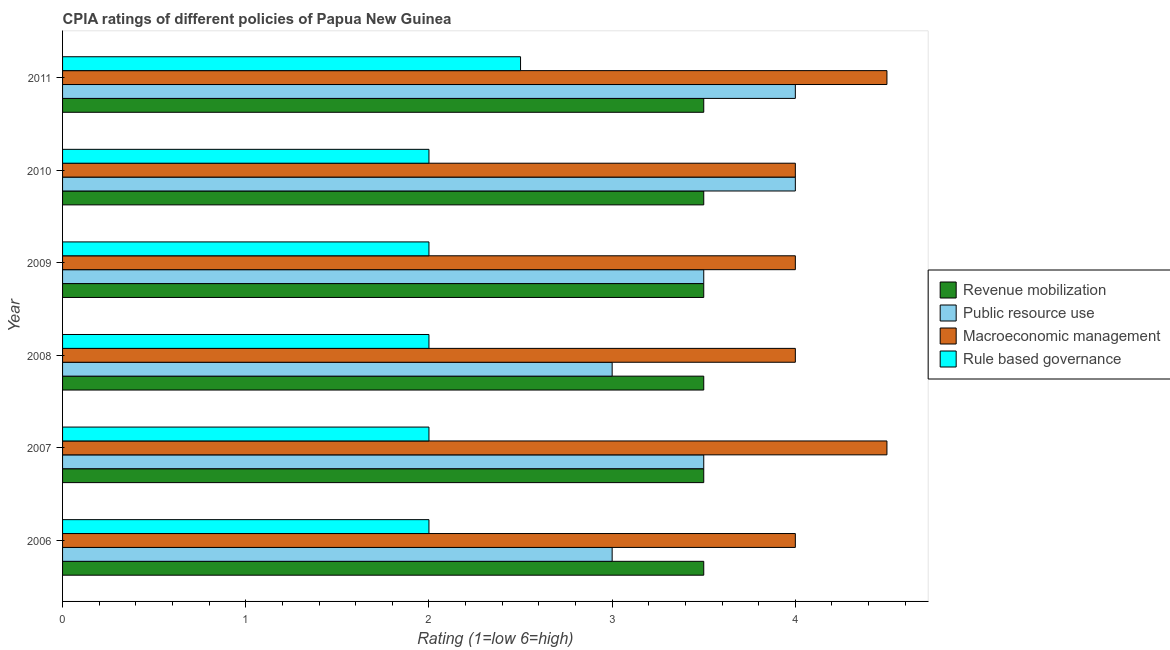How many groups of bars are there?
Provide a succinct answer. 6. Are the number of bars on each tick of the Y-axis equal?
Ensure brevity in your answer.  Yes. What is the label of the 1st group of bars from the top?
Your response must be concise. 2011. In how many cases, is the number of bars for a given year not equal to the number of legend labels?
Your answer should be very brief. 0. Across all years, what is the maximum cpia rating of public resource use?
Your response must be concise. 4. Across all years, what is the minimum cpia rating of macroeconomic management?
Ensure brevity in your answer.  4. What is the total cpia rating of revenue mobilization in the graph?
Provide a short and direct response. 21. What is the difference between the cpia rating of rule based governance in 2006 and that in 2009?
Provide a short and direct response. 0. What is the average cpia rating of macroeconomic management per year?
Your answer should be compact. 4.17. In how many years, is the cpia rating of public resource use greater than 2.8 ?
Your answer should be compact. 6. What is the ratio of the cpia rating of rule based governance in 2006 to that in 2007?
Your answer should be very brief. 1. What is the difference between the highest and the second highest cpia rating of revenue mobilization?
Provide a succinct answer. 0. What is the difference between the highest and the lowest cpia rating of macroeconomic management?
Ensure brevity in your answer.  0.5. In how many years, is the cpia rating of public resource use greater than the average cpia rating of public resource use taken over all years?
Make the answer very short. 2. Is the sum of the cpia rating of rule based governance in 2006 and 2009 greater than the maximum cpia rating of macroeconomic management across all years?
Your answer should be very brief. No. Is it the case that in every year, the sum of the cpia rating of public resource use and cpia rating of rule based governance is greater than the sum of cpia rating of macroeconomic management and cpia rating of revenue mobilization?
Offer a very short reply. No. What does the 4th bar from the top in 2006 represents?
Give a very brief answer. Revenue mobilization. What does the 1st bar from the bottom in 2007 represents?
Ensure brevity in your answer.  Revenue mobilization. Is it the case that in every year, the sum of the cpia rating of revenue mobilization and cpia rating of public resource use is greater than the cpia rating of macroeconomic management?
Offer a terse response. Yes. Does the graph contain any zero values?
Offer a very short reply. No. Does the graph contain grids?
Offer a very short reply. No. How many legend labels are there?
Your answer should be very brief. 4. What is the title of the graph?
Your response must be concise. CPIA ratings of different policies of Papua New Guinea. Does "Taxes on income" appear as one of the legend labels in the graph?
Ensure brevity in your answer.  No. What is the label or title of the Y-axis?
Provide a short and direct response. Year. What is the Rating (1=low 6=high) of Revenue mobilization in 2006?
Provide a short and direct response. 3.5. What is the Rating (1=low 6=high) in Macroeconomic management in 2006?
Give a very brief answer. 4. What is the Rating (1=low 6=high) in Rule based governance in 2006?
Your response must be concise. 2. What is the Rating (1=low 6=high) of Public resource use in 2007?
Ensure brevity in your answer.  3.5. What is the Rating (1=low 6=high) in Macroeconomic management in 2007?
Provide a succinct answer. 4.5. What is the Rating (1=low 6=high) of Revenue mobilization in 2008?
Your answer should be very brief. 3.5. What is the Rating (1=low 6=high) of Macroeconomic management in 2008?
Provide a short and direct response. 4. What is the Rating (1=low 6=high) in Public resource use in 2009?
Ensure brevity in your answer.  3.5. What is the Rating (1=low 6=high) of Macroeconomic management in 2009?
Provide a short and direct response. 4. What is the Rating (1=low 6=high) of Rule based governance in 2009?
Provide a short and direct response. 2. What is the Rating (1=low 6=high) of Revenue mobilization in 2010?
Offer a terse response. 3.5. What is the Rating (1=low 6=high) in Public resource use in 2010?
Your response must be concise. 4. What is the Rating (1=low 6=high) of Macroeconomic management in 2010?
Offer a very short reply. 4. What is the Rating (1=low 6=high) in Public resource use in 2011?
Provide a short and direct response. 4. What is the Rating (1=low 6=high) in Macroeconomic management in 2011?
Offer a very short reply. 4.5. What is the Rating (1=low 6=high) of Rule based governance in 2011?
Make the answer very short. 2.5. Across all years, what is the maximum Rating (1=low 6=high) in Revenue mobilization?
Provide a short and direct response. 3.5. Across all years, what is the maximum Rating (1=low 6=high) of Public resource use?
Provide a short and direct response. 4. Across all years, what is the minimum Rating (1=low 6=high) in Revenue mobilization?
Keep it short and to the point. 3.5. What is the total Rating (1=low 6=high) of Public resource use in the graph?
Ensure brevity in your answer.  21. What is the difference between the Rating (1=low 6=high) in Revenue mobilization in 2006 and that in 2007?
Your answer should be compact. 0. What is the difference between the Rating (1=low 6=high) in Revenue mobilization in 2006 and that in 2008?
Give a very brief answer. 0. What is the difference between the Rating (1=low 6=high) of Public resource use in 2006 and that in 2008?
Your answer should be very brief. 0. What is the difference between the Rating (1=low 6=high) in Rule based governance in 2006 and that in 2008?
Offer a very short reply. 0. What is the difference between the Rating (1=low 6=high) in Revenue mobilization in 2006 and that in 2009?
Make the answer very short. 0. What is the difference between the Rating (1=low 6=high) in Revenue mobilization in 2006 and that in 2010?
Provide a short and direct response. 0. What is the difference between the Rating (1=low 6=high) of Macroeconomic management in 2006 and that in 2010?
Ensure brevity in your answer.  0. What is the difference between the Rating (1=low 6=high) of Rule based governance in 2006 and that in 2010?
Provide a short and direct response. 0. What is the difference between the Rating (1=low 6=high) in Public resource use in 2006 and that in 2011?
Offer a very short reply. -1. What is the difference between the Rating (1=low 6=high) in Public resource use in 2007 and that in 2008?
Provide a succinct answer. 0.5. What is the difference between the Rating (1=low 6=high) in Rule based governance in 2007 and that in 2008?
Your answer should be very brief. 0. What is the difference between the Rating (1=low 6=high) in Public resource use in 2007 and that in 2009?
Offer a very short reply. 0. What is the difference between the Rating (1=low 6=high) of Rule based governance in 2007 and that in 2009?
Ensure brevity in your answer.  0. What is the difference between the Rating (1=low 6=high) of Revenue mobilization in 2007 and that in 2010?
Provide a succinct answer. 0. What is the difference between the Rating (1=low 6=high) in Public resource use in 2007 and that in 2010?
Your answer should be very brief. -0.5. What is the difference between the Rating (1=low 6=high) in Macroeconomic management in 2007 and that in 2010?
Offer a very short reply. 0.5. What is the difference between the Rating (1=low 6=high) of Revenue mobilization in 2007 and that in 2011?
Make the answer very short. 0. What is the difference between the Rating (1=low 6=high) of Revenue mobilization in 2008 and that in 2009?
Give a very brief answer. 0. What is the difference between the Rating (1=low 6=high) in Macroeconomic management in 2008 and that in 2009?
Give a very brief answer. 0. What is the difference between the Rating (1=low 6=high) of Macroeconomic management in 2008 and that in 2010?
Ensure brevity in your answer.  0. What is the difference between the Rating (1=low 6=high) in Rule based governance in 2008 and that in 2010?
Provide a succinct answer. 0. What is the difference between the Rating (1=low 6=high) in Public resource use in 2008 and that in 2011?
Offer a very short reply. -1. What is the difference between the Rating (1=low 6=high) in Macroeconomic management in 2008 and that in 2011?
Your response must be concise. -0.5. What is the difference between the Rating (1=low 6=high) of Rule based governance in 2008 and that in 2011?
Your response must be concise. -0.5. What is the difference between the Rating (1=low 6=high) in Macroeconomic management in 2009 and that in 2010?
Your response must be concise. 0. What is the difference between the Rating (1=low 6=high) in Revenue mobilization in 2009 and that in 2011?
Your answer should be very brief. 0. What is the difference between the Rating (1=low 6=high) of Public resource use in 2009 and that in 2011?
Give a very brief answer. -0.5. What is the difference between the Rating (1=low 6=high) of Macroeconomic management in 2009 and that in 2011?
Your response must be concise. -0.5. What is the difference between the Rating (1=low 6=high) of Public resource use in 2010 and that in 2011?
Your answer should be very brief. 0. What is the difference between the Rating (1=low 6=high) in Revenue mobilization in 2006 and the Rating (1=low 6=high) in Public resource use in 2007?
Make the answer very short. 0. What is the difference between the Rating (1=low 6=high) in Revenue mobilization in 2006 and the Rating (1=low 6=high) in Macroeconomic management in 2007?
Make the answer very short. -1. What is the difference between the Rating (1=low 6=high) of Public resource use in 2006 and the Rating (1=low 6=high) of Macroeconomic management in 2007?
Offer a very short reply. -1.5. What is the difference between the Rating (1=low 6=high) in Revenue mobilization in 2006 and the Rating (1=low 6=high) in Public resource use in 2008?
Offer a very short reply. 0.5. What is the difference between the Rating (1=low 6=high) in Revenue mobilization in 2006 and the Rating (1=low 6=high) in Macroeconomic management in 2008?
Provide a succinct answer. -0.5. What is the difference between the Rating (1=low 6=high) in Revenue mobilization in 2006 and the Rating (1=low 6=high) in Rule based governance in 2008?
Your response must be concise. 1.5. What is the difference between the Rating (1=low 6=high) of Revenue mobilization in 2006 and the Rating (1=low 6=high) of Rule based governance in 2009?
Offer a very short reply. 1.5. What is the difference between the Rating (1=low 6=high) of Public resource use in 2006 and the Rating (1=low 6=high) of Rule based governance in 2009?
Ensure brevity in your answer.  1. What is the difference between the Rating (1=low 6=high) of Revenue mobilization in 2006 and the Rating (1=low 6=high) of Public resource use in 2010?
Provide a succinct answer. -0.5. What is the difference between the Rating (1=low 6=high) in Revenue mobilization in 2006 and the Rating (1=low 6=high) in Rule based governance in 2010?
Your answer should be very brief. 1.5. What is the difference between the Rating (1=low 6=high) in Revenue mobilization in 2006 and the Rating (1=low 6=high) in Public resource use in 2011?
Provide a succinct answer. -0.5. What is the difference between the Rating (1=low 6=high) in Revenue mobilization in 2006 and the Rating (1=low 6=high) in Macroeconomic management in 2011?
Provide a short and direct response. -1. What is the difference between the Rating (1=low 6=high) in Macroeconomic management in 2006 and the Rating (1=low 6=high) in Rule based governance in 2011?
Give a very brief answer. 1.5. What is the difference between the Rating (1=low 6=high) in Revenue mobilization in 2007 and the Rating (1=low 6=high) in Macroeconomic management in 2008?
Your response must be concise. -0.5. What is the difference between the Rating (1=low 6=high) in Revenue mobilization in 2007 and the Rating (1=low 6=high) in Rule based governance in 2008?
Provide a succinct answer. 1.5. What is the difference between the Rating (1=low 6=high) in Macroeconomic management in 2007 and the Rating (1=low 6=high) in Rule based governance in 2008?
Your answer should be very brief. 2.5. What is the difference between the Rating (1=low 6=high) in Revenue mobilization in 2007 and the Rating (1=low 6=high) in Macroeconomic management in 2009?
Your answer should be very brief. -0.5. What is the difference between the Rating (1=low 6=high) in Revenue mobilization in 2007 and the Rating (1=low 6=high) in Rule based governance in 2009?
Keep it short and to the point. 1.5. What is the difference between the Rating (1=low 6=high) in Public resource use in 2007 and the Rating (1=low 6=high) in Macroeconomic management in 2009?
Give a very brief answer. -0.5. What is the difference between the Rating (1=low 6=high) in Public resource use in 2007 and the Rating (1=low 6=high) in Rule based governance in 2009?
Your response must be concise. 1.5. What is the difference between the Rating (1=low 6=high) in Revenue mobilization in 2007 and the Rating (1=low 6=high) in Public resource use in 2010?
Provide a short and direct response. -0.5. What is the difference between the Rating (1=low 6=high) in Revenue mobilization in 2007 and the Rating (1=low 6=high) in Macroeconomic management in 2010?
Keep it short and to the point. -0.5. What is the difference between the Rating (1=low 6=high) in Macroeconomic management in 2007 and the Rating (1=low 6=high) in Rule based governance in 2010?
Make the answer very short. 2.5. What is the difference between the Rating (1=low 6=high) in Revenue mobilization in 2007 and the Rating (1=low 6=high) in Public resource use in 2011?
Provide a short and direct response. -0.5. What is the difference between the Rating (1=low 6=high) of Revenue mobilization in 2007 and the Rating (1=low 6=high) of Rule based governance in 2011?
Your answer should be very brief. 1. What is the difference between the Rating (1=low 6=high) of Public resource use in 2007 and the Rating (1=low 6=high) of Macroeconomic management in 2011?
Offer a terse response. -1. What is the difference between the Rating (1=low 6=high) of Public resource use in 2007 and the Rating (1=low 6=high) of Rule based governance in 2011?
Your answer should be very brief. 1. What is the difference between the Rating (1=low 6=high) in Macroeconomic management in 2007 and the Rating (1=low 6=high) in Rule based governance in 2011?
Your response must be concise. 2. What is the difference between the Rating (1=low 6=high) in Revenue mobilization in 2008 and the Rating (1=low 6=high) in Macroeconomic management in 2009?
Give a very brief answer. -0.5. What is the difference between the Rating (1=low 6=high) in Public resource use in 2008 and the Rating (1=low 6=high) in Rule based governance in 2009?
Your response must be concise. 1. What is the difference between the Rating (1=low 6=high) in Macroeconomic management in 2008 and the Rating (1=low 6=high) in Rule based governance in 2009?
Your answer should be compact. 2. What is the difference between the Rating (1=low 6=high) of Revenue mobilization in 2008 and the Rating (1=low 6=high) of Public resource use in 2010?
Give a very brief answer. -0.5. What is the difference between the Rating (1=low 6=high) in Revenue mobilization in 2008 and the Rating (1=low 6=high) in Macroeconomic management in 2010?
Offer a very short reply. -0.5. What is the difference between the Rating (1=low 6=high) of Revenue mobilization in 2008 and the Rating (1=low 6=high) of Rule based governance in 2010?
Offer a very short reply. 1.5. What is the difference between the Rating (1=low 6=high) of Public resource use in 2008 and the Rating (1=low 6=high) of Macroeconomic management in 2010?
Your answer should be very brief. -1. What is the difference between the Rating (1=low 6=high) of Revenue mobilization in 2008 and the Rating (1=low 6=high) of Public resource use in 2011?
Provide a succinct answer. -0.5. What is the difference between the Rating (1=low 6=high) in Revenue mobilization in 2008 and the Rating (1=low 6=high) in Rule based governance in 2011?
Your answer should be compact. 1. What is the difference between the Rating (1=low 6=high) in Public resource use in 2008 and the Rating (1=low 6=high) in Macroeconomic management in 2011?
Your answer should be very brief. -1.5. What is the difference between the Rating (1=low 6=high) of Public resource use in 2008 and the Rating (1=low 6=high) of Rule based governance in 2011?
Your answer should be very brief. 0.5. What is the difference between the Rating (1=low 6=high) in Macroeconomic management in 2008 and the Rating (1=low 6=high) in Rule based governance in 2011?
Your answer should be compact. 1.5. What is the difference between the Rating (1=low 6=high) in Revenue mobilization in 2009 and the Rating (1=low 6=high) in Rule based governance in 2010?
Keep it short and to the point. 1.5. What is the difference between the Rating (1=low 6=high) of Public resource use in 2009 and the Rating (1=low 6=high) of Rule based governance in 2010?
Offer a terse response. 1.5. What is the difference between the Rating (1=low 6=high) of Macroeconomic management in 2009 and the Rating (1=low 6=high) of Rule based governance in 2010?
Your response must be concise. 2. What is the difference between the Rating (1=low 6=high) in Revenue mobilization in 2009 and the Rating (1=low 6=high) in Public resource use in 2011?
Offer a terse response. -0.5. What is the difference between the Rating (1=low 6=high) of Public resource use in 2009 and the Rating (1=low 6=high) of Macroeconomic management in 2011?
Your answer should be compact. -1. What is the difference between the Rating (1=low 6=high) of Macroeconomic management in 2009 and the Rating (1=low 6=high) of Rule based governance in 2011?
Your response must be concise. 1.5. What is the difference between the Rating (1=low 6=high) in Revenue mobilization in 2010 and the Rating (1=low 6=high) in Rule based governance in 2011?
Your answer should be compact. 1. What is the difference between the Rating (1=low 6=high) in Public resource use in 2010 and the Rating (1=low 6=high) in Rule based governance in 2011?
Your answer should be very brief. 1.5. What is the average Rating (1=low 6=high) in Macroeconomic management per year?
Offer a terse response. 4.17. What is the average Rating (1=low 6=high) of Rule based governance per year?
Your response must be concise. 2.08. In the year 2006, what is the difference between the Rating (1=low 6=high) of Public resource use and Rating (1=low 6=high) of Macroeconomic management?
Ensure brevity in your answer.  -1. In the year 2006, what is the difference between the Rating (1=low 6=high) in Macroeconomic management and Rating (1=low 6=high) in Rule based governance?
Keep it short and to the point. 2. In the year 2007, what is the difference between the Rating (1=low 6=high) of Revenue mobilization and Rating (1=low 6=high) of Macroeconomic management?
Ensure brevity in your answer.  -1. In the year 2007, what is the difference between the Rating (1=low 6=high) in Public resource use and Rating (1=low 6=high) in Rule based governance?
Ensure brevity in your answer.  1.5. In the year 2008, what is the difference between the Rating (1=low 6=high) of Revenue mobilization and Rating (1=low 6=high) of Macroeconomic management?
Offer a terse response. -0.5. In the year 2008, what is the difference between the Rating (1=low 6=high) of Public resource use and Rating (1=low 6=high) of Macroeconomic management?
Make the answer very short. -1. In the year 2009, what is the difference between the Rating (1=low 6=high) in Macroeconomic management and Rating (1=low 6=high) in Rule based governance?
Your answer should be very brief. 2. In the year 2010, what is the difference between the Rating (1=low 6=high) of Revenue mobilization and Rating (1=low 6=high) of Public resource use?
Give a very brief answer. -0.5. In the year 2010, what is the difference between the Rating (1=low 6=high) in Revenue mobilization and Rating (1=low 6=high) in Macroeconomic management?
Offer a very short reply. -0.5. In the year 2010, what is the difference between the Rating (1=low 6=high) of Macroeconomic management and Rating (1=low 6=high) of Rule based governance?
Your response must be concise. 2. In the year 2011, what is the difference between the Rating (1=low 6=high) in Revenue mobilization and Rating (1=low 6=high) in Public resource use?
Provide a short and direct response. -0.5. In the year 2011, what is the difference between the Rating (1=low 6=high) in Revenue mobilization and Rating (1=low 6=high) in Macroeconomic management?
Provide a succinct answer. -1. In the year 2011, what is the difference between the Rating (1=low 6=high) of Public resource use and Rating (1=low 6=high) of Macroeconomic management?
Ensure brevity in your answer.  -0.5. In the year 2011, what is the difference between the Rating (1=low 6=high) in Public resource use and Rating (1=low 6=high) in Rule based governance?
Offer a very short reply. 1.5. What is the ratio of the Rating (1=low 6=high) in Public resource use in 2006 to that in 2008?
Give a very brief answer. 1. What is the ratio of the Rating (1=low 6=high) of Revenue mobilization in 2006 to that in 2009?
Give a very brief answer. 1. What is the ratio of the Rating (1=low 6=high) of Public resource use in 2006 to that in 2009?
Give a very brief answer. 0.86. What is the ratio of the Rating (1=low 6=high) in Public resource use in 2006 to that in 2010?
Your response must be concise. 0.75. What is the ratio of the Rating (1=low 6=high) in Rule based governance in 2006 to that in 2010?
Your response must be concise. 1. What is the ratio of the Rating (1=low 6=high) in Macroeconomic management in 2006 to that in 2011?
Offer a terse response. 0.89. What is the ratio of the Rating (1=low 6=high) of Public resource use in 2007 to that in 2008?
Make the answer very short. 1.17. What is the ratio of the Rating (1=low 6=high) in Macroeconomic management in 2007 to that in 2008?
Offer a very short reply. 1.12. What is the ratio of the Rating (1=low 6=high) of Rule based governance in 2007 to that in 2008?
Your answer should be very brief. 1. What is the ratio of the Rating (1=low 6=high) of Revenue mobilization in 2007 to that in 2011?
Offer a terse response. 1. What is the ratio of the Rating (1=low 6=high) in Public resource use in 2007 to that in 2011?
Your answer should be very brief. 0.88. What is the ratio of the Rating (1=low 6=high) of Revenue mobilization in 2008 to that in 2009?
Make the answer very short. 1. What is the ratio of the Rating (1=low 6=high) in Macroeconomic management in 2008 to that in 2009?
Give a very brief answer. 1. What is the ratio of the Rating (1=low 6=high) of Rule based governance in 2008 to that in 2009?
Offer a very short reply. 1. What is the ratio of the Rating (1=low 6=high) of Revenue mobilization in 2008 to that in 2010?
Your response must be concise. 1. What is the ratio of the Rating (1=low 6=high) in Public resource use in 2008 to that in 2010?
Provide a succinct answer. 0.75. What is the ratio of the Rating (1=low 6=high) in Macroeconomic management in 2008 to that in 2010?
Offer a very short reply. 1. What is the ratio of the Rating (1=low 6=high) in Rule based governance in 2008 to that in 2010?
Offer a very short reply. 1. What is the ratio of the Rating (1=low 6=high) of Revenue mobilization in 2008 to that in 2011?
Your answer should be very brief. 1. What is the ratio of the Rating (1=low 6=high) in Macroeconomic management in 2008 to that in 2011?
Your response must be concise. 0.89. What is the ratio of the Rating (1=low 6=high) of Rule based governance in 2008 to that in 2011?
Make the answer very short. 0.8. What is the ratio of the Rating (1=low 6=high) of Revenue mobilization in 2009 to that in 2010?
Ensure brevity in your answer.  1. What is the ratio of the Rating (1=low 6=high) of Public resource use in 2009 to that in 2010?
Give a very brief answer. 0.88. What is the ratio of the Rating (1=low 6=high) of Rule based governance in 2009 to that in 2010?
Your answer should be very brief. 1. What is the ratio of the Rating (1=low 6=high) of Public resource use in 2009 to that in 2011?
Give a very brief answer. 0.88. What is the ratio of the Rating (1=low 6=high) in Rule based governance in 2009 to that in 2011?
Keep it short and to the point. 0.8. What is the ratio of the Rating (1=low 6=high) in Public resource use in 2010 to that in 2011?
Offer a very short reply. 1. What is the ratio of the Rating (1=low 6=high) of Macroeconomic management in 2010 to that in 2011?
Keep it short and to the point. 0.89. What is the ratio of the Rating (1=low 6=high) of Rule based governance in 2010 to that in 2011?
Provide a short and direct response. 0.8. What is the difference between the highest and the lowest Rating (1=low 6=high) in Revenue mobilization?
Your response must be concise. 0. What is the difference between the highest and the lowest Rating (1=low 6=high) of Rule based governance?
Your response must be concise. 0.5. 